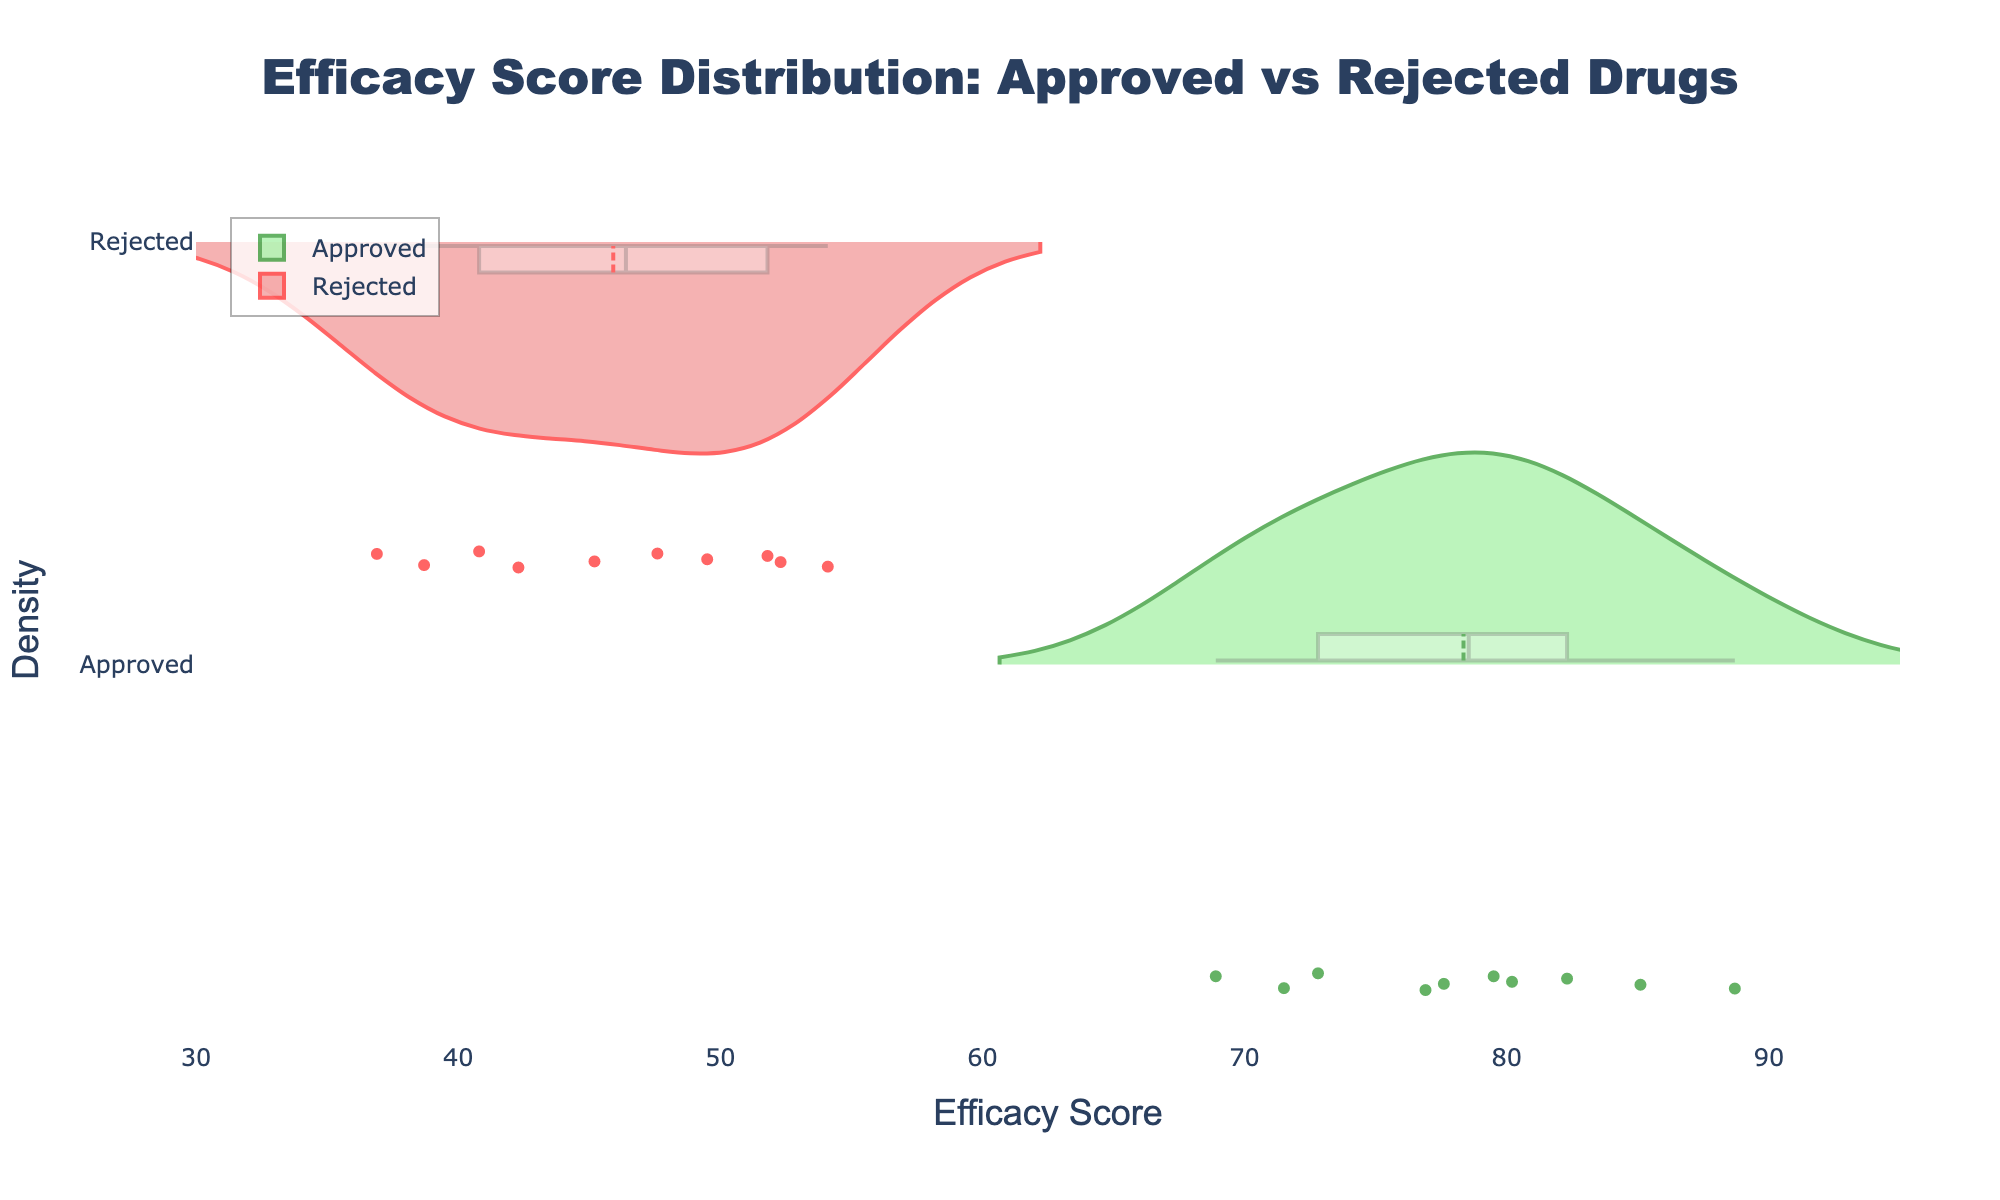How many drugs are represented in the plot? By counting the number of data points on the plot, including both approved and rejected drugs, we find there are 20 data points in total.
Answer: 20 What are the axis labels, and what units are they in? The x-axis is labeled "Efficacy Score," and the y-axis is labeled "Density." There are no specific units given for density, but the efficacy score is likely measured as a percentage.
Answer: Efficacy Score, Density What is the title of the plot? The title is displayed at the top of the plot and reads "Efficacy Score Distribution: Approved vs Rejected Drugs."
Answer: Efficacy Score Distribution: Approved vs Rejected Drugs Which group, approved or rejected, shows a higher density of higher efficacy scores? By observing the density plots, we can see that the approved drugs show a higher density of efficacy scores in the higher range (around 80-90) compared to rejected drugs.
Answer: Approved What is the mean efficacy score of the approved drugs? The mean efficacy score for the approved drugs is indicated by the mean line on the density plot for the approved drugs. This value appears to be around 80.
Answer: Around 80 Is there any overlap in the efficacy score distributions of approved and rejected drugs? By examining the density plots, we can see that there is no significant overlap between the efficacy score distributions of approved and rejected drugs, as approved drugs have higher efficacy scores and rejected drugs have lower scores.
Answer: No Which drug group has a wider spread in efficacy scores, approved or rejected? By comparing the shape and spread of the violin plots, it is evident that the rejected drugs have a wider spread in efficacy scores, ranging approximately from 35 to 55, whereas approved drugs are concentrated between 70 to 90.
Answer: Rejected What percentage of approved drugs have an efficacy score above 75? Observing the density plot for approved drugs and the visual concentration of points above the x-axis value of 75, we can estimate that the majority of approved drugs (around 80-90%) have efficacy scores above this value.
Answer: Around 80-90% Which efficacy score has the highest density among rejected drugs? Looking at the peak of the density plot for rejected drugs, the efficacy score with the highest density is approximately around 50.
Answer: Around 50 Are there any approved drugs with an efficacy score below 70? By observing the violin plot for approved drugs, there are no data points below an efficacy score of 70, indicating that all approved drugs have efficacy scores above 70.
Answer: No 